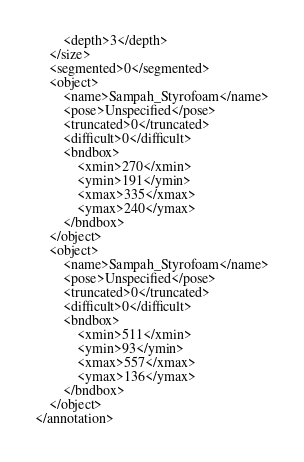<code> <loc_0><loc_0><loc_500><loc_500><_XML_>		<depth>3</depth>
	</size>
	<segmented>0</segmented>
	<object>
		<name>Sampah_Styrofoam</name>
		<pose>Unspecified</pose>
		<truncated>0</truncated>
		<difficult>0</difficult>
		<bndbox>
			<xmin>270</xmin>
			<ymin>191</ymin>
			<xmax>335</xmax>
			<ymax>240</ymax>
		</bndbox>
	</object>
	<object>
		<name>Sampah_Styrofoam</name>
		<pose>Unspecified</pose>
		<truncated>0</truncated>
		<difficult>0</difficult>
		<bndbox>
			<xmin>511</xmin>
			<ymin>93</ymin>
			<xmax>557</xmax>
			<ymax>136</ymax>
		</bndbox>
	</object>
</annotation>
</code> 